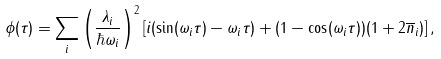Convert formula to latex. <formula><loc_0><loc_0><loc_500><loc_500>\phi ( \tau ) = \sum _ { i } \left ( \frac { \lambda _ { i } } { \hbar { \omega } _ { i } } \right ) ^ { 2 } \left [ i ( \sin ( \omega _ { i } \tau ) - \omega _ { i } \tau ) + ( 1 - \cos ( \omega _ { i } \tau ) ) ( 1 + 2 \overline { n } _ { i } ) \right ] ,</formula> 